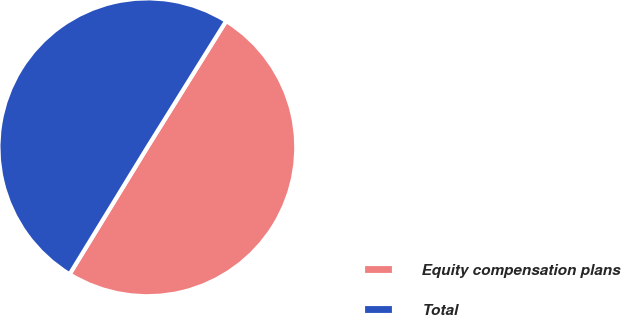<chart> <loc_0><loc_0><loc_500><loc_500><pie_chart><fcel>Equity compensation plans<fcel>Total<nl><fcel>49.87%<fcel>50.13%<nl></chart> 